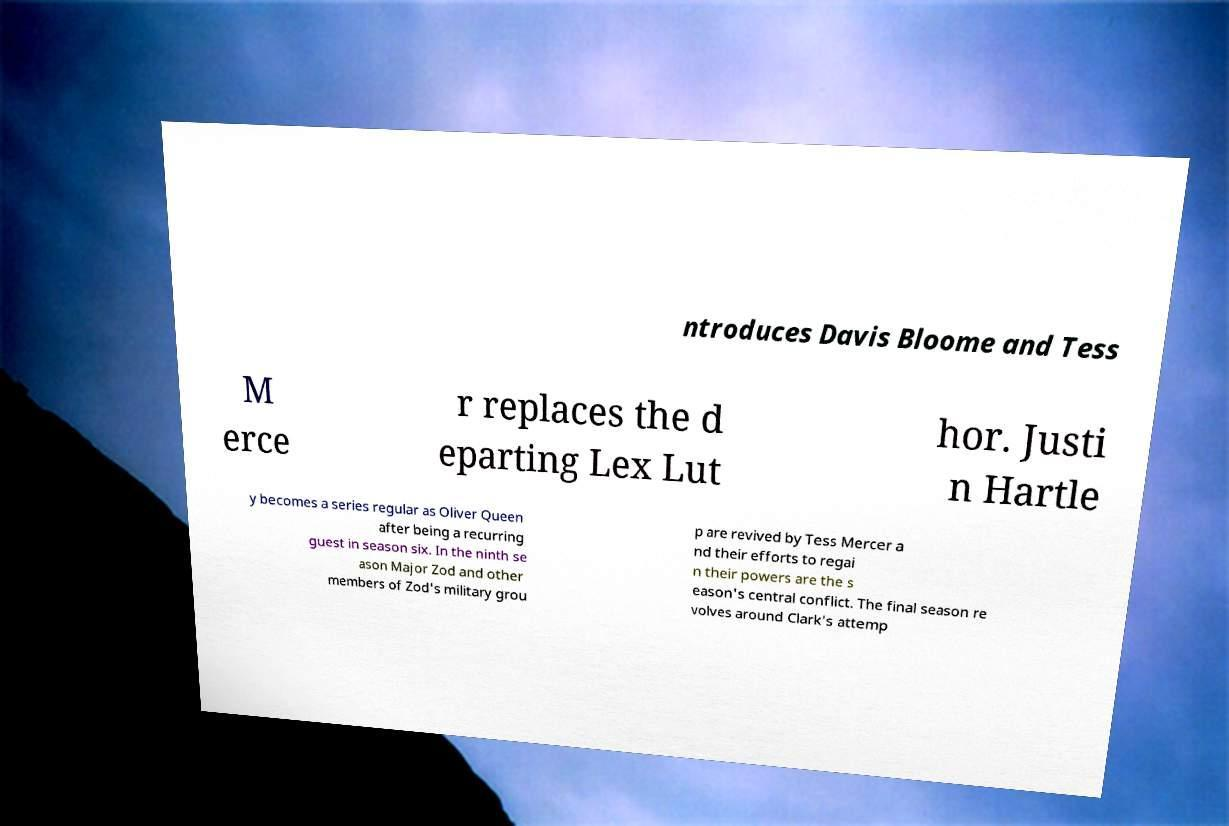Can you accurately transcribe the text from the provided image for me? ntroduces Davis Bloome and Tess M erce r replaces the d eparting Lex Lut hor. Justi n Hartle y becomes a series regular as Oliver Queen after being a recurring guest in season six. In the ninth se ason Major Zod and other members of Zod's military grou p are revived by Tess Mercer a nd their efforts to regai n their powers are the s eason's central conflict. The final season re volves around Clark's attemp 